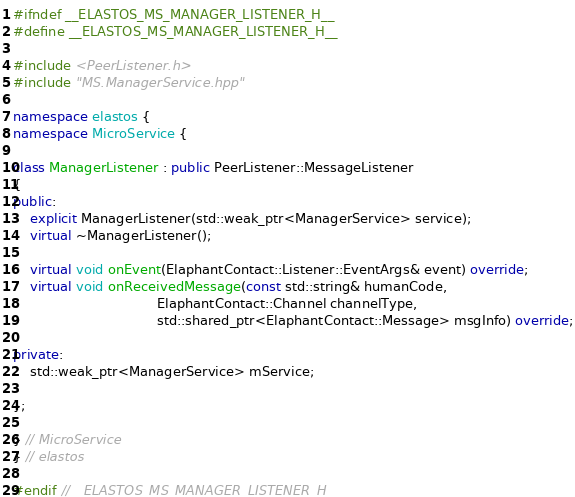<code> <loc_0><loc_0><loc_500><loc_500><_C++_>#ifndef __ELASTOS_MS_MANAGER_LISTENER_H__
#define __ELASTOS_MS_MANAGER_LISTENER_H__

#include <PeerListener.h>
#include "MS.ManagerService.hpp"

namespace elastos {
namespace MicroService {

class ManagerListener : public PeerListener::MessageListener
{
public:
    explicit ManagerListener(std::weak_ptr<ManagerService> service);
    virtual ~ManagerListener();

    virtual void onEvent(ElaphantContact::Listener::EventArgs& event) override;
    virtual void onReceivedMessage(const std::string& humanCode,
                                   ElaphantContact::Channel channelType,
                                   std::shared_ptr<ElaphantContact::Message> msgInfo) override;

private:
    std::weak_ptr<ManagerService> mService;

};

} // MicroService
} // elastos

#endif //__ELASTOS_MS_MANAGER_LISTENER_H__
</code> 